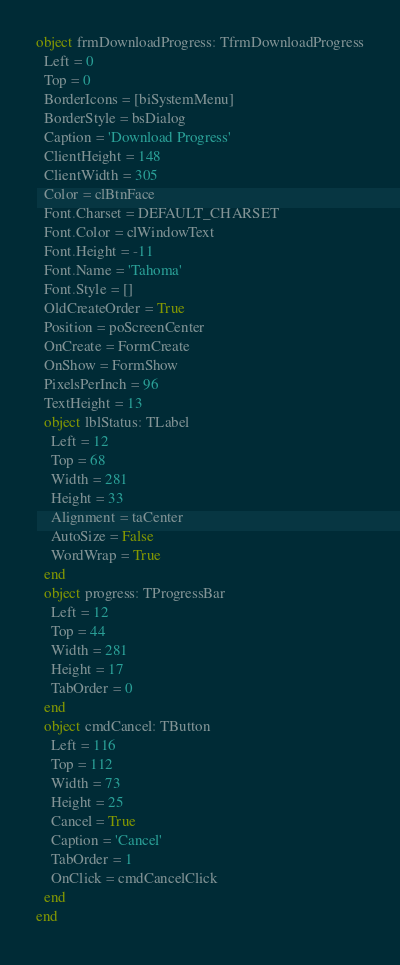Convert code to text. <code><loc_0><loc_0><loc_500><loc_500><_Pascal_>object frmDownloadProgress: TfrmDownloadProgress
  Left = 0
  Top = 0
  BorderIcons = [biSystemMenu]
  BorderStyle = bsDialog
  Caption = 'Download Progress'
  ClientHeight = 148
  ClientWidth = 305
  Color = clBtnFace
  Font.Charset = DEFAULT_CHARSET
  Font.Color = clWindowText
  Font.Height = -11
  Font.Name = 'Tahoma'
  Font.Style = []
  OldCreateOrder = True
  Position = poScreenCenter
  OnCreate = FormCreate
  OnShow = FormShow
  PixelsPerInch = 96
  TextHeight = 13
  object lblStatus: TLabel
    Left = 12
    Top = 68
    Width = 281
    Height = 33
    Alignment = taCenter
    AutoSize = False
    WordWrap = True
  end
  object progress: TProgressBar
    Left = 12
    Top = 44
    Width = 281
    Height = 17
    TabOrder = 0
  end
  object cmdCancel: TButton
    Left = 116
    Top = 112
    Width = 73
    Height = 25
    Cancel = True
    Caption = 'Cancel'
    TabOrder = 1
    OnClick = cmdCancelClick
  end
end
</code> 